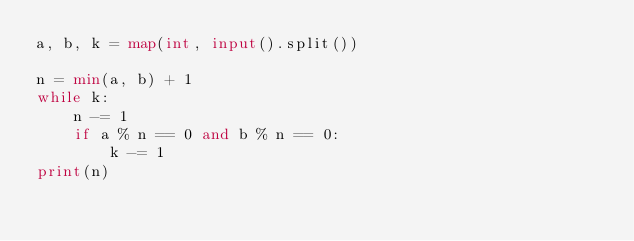Convert code to text. <code><loc_0><loc_0><loc_500><loc_500><_Python_>a, b, k = map(int, input().split())                                             

n = min(a, b) + 1 
while k:
    n -= 1
    if a % n == 0 and b % n == 0:
        k -= 1
print(n)</code> 